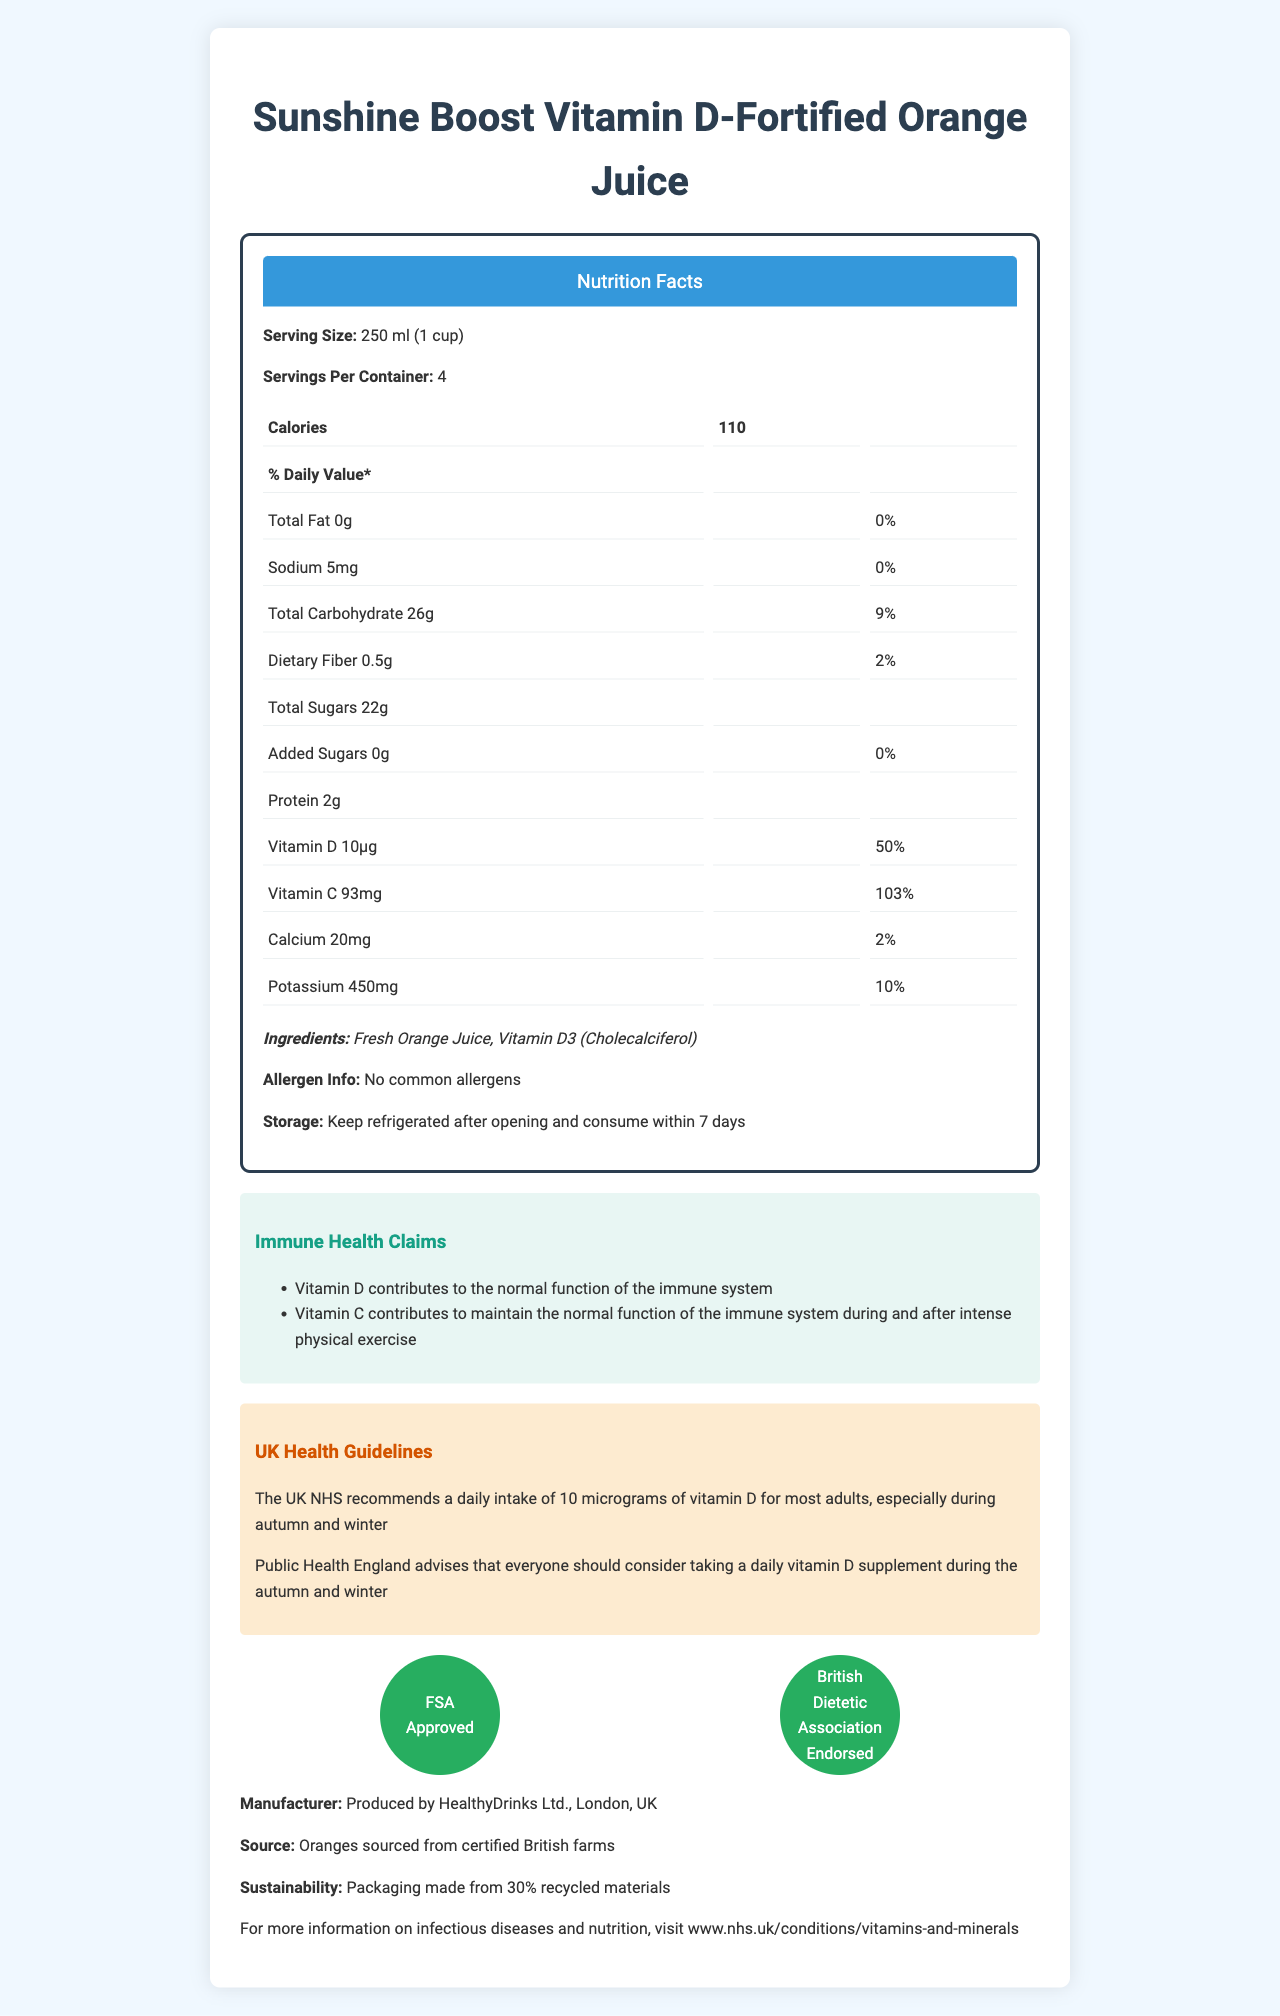How much Vitamin D does one serving of the Sunshine Boost Vitamin D-Fortified Orange Juice provide? The document lists the amount of Vitamin D per serving as 10 micrograms under the nutritional information.
Answer: 10µg What is the serving size of Sunshine Boost Vitamin D-Fortified Orange Juice? The serving size is specified as 250 ml (1 cup) in the document.
Answer: 250 ml (1 cup) How many servings are there per container? The document states that there are 4 servings per container.
Answer: 4 What are the two main ingredients in the Sunshine Boost Vitamin D-Fortified Orange Juice? The ingredients section of the document lists Fresh Orange Juice and Vitamin D3 (Cholecalciferol) as the main ingredients.
Answer: Fresh Orange Juice, Vitamin D3 (Cholecalciferol) What percentage of the daily value of Vitamin C does one serving provide? Under the nutritional information, it is stated that one serving provides 103% of the daily value of Vitamin C.
Answer: 103% What health claims are associated with Sunshine Boost Vitamin D-Fortified Orange Juice? A. Supports cardiovascular health B. Supports immune function C. Aids in digestion    D. Improves bone density The document's immune health claims section mentions that Vitamin D and Vitamin C contribute to the normal function of the immune system.
Answer: B Which certification is NOT held by Sunshine Boost Vitamin D-Fortified Orange Juice? A. FSA Approved B. British Dietetic Association Endorsed C. USDA Organic D. None of the above The document lists "FSA Approved" and "British Dietetic Association Endorsed" as certifications but does not mention "USDA Organic".
Answer: C Does the product contain any common allergens? The allergen info section of the document clearly states that there are no common allergens in the product.
Answer: No According to the document, what is the recommended daily intake of Vitamin D by the UK NHS? The UK NHS guidelines section recommends a daily intake of 10 micrograms of Vitamin D for most adults.
Answer: 10 micrograms Summarize the main idea presented in this document. This document primarily describes the nutritional benefits, particularly the immune-supporting Vitamin D and Vitamin C content, certifications, ingredient details, and sustainability efforts of the Sunshine Boost Vitamin D-Fortified Orange Juice.
Answer: The Sunshine Boost Vitamin D-Fortified Orange Juice is a nutritious beverage providing 10 micrograms of Vitamin D and 93 milligrams of Vitamin C per serving, which support immune function. It is made from fresh orange juice and contains no common allergens. The product is FSA approved and endorsed by the British Dietetic Association. Additionally, the packaging is environmentally friendly, made from 30% recycled materials. How much sugar is added to the Sunshine Boost Vitamin D-Fortified Orange Juice? The total sugars section of the document indicates that the amount of added sugars is 0g.
Answer: 0g What is the percentage of daily value for calcium provided by one serving of the juice? According to the nutritional information, one serving provides 2% of the daily value for calcium.
Answer: 2% What is the company's advice regarding the intake of Vitamin D during autumn and winter? This advice is stated clearly in the UK health guidelines section of the document.
Answer: Public Health England advises that everyone should consider taking a daily vitamin D supplement during the autumn and winter. Where are the oranges sourced from? The source info section mentions that the oranges are sourced from certified British farms.
Answer: Certified British farms What does Public Health England say about taking vitamin D supplements? This is mentioned in the UK health guidelines section of the document.
Answer: Public Health England advises that everyone should consider taking a daily vitamin D supplement during the autumn and winter. Does the product need to be refrigerated after opening? The storage instructions specify that the product should be refrigerated after opening and consumed within 7 days.
Answer: Yes What are the sustainability features of the product's packaging? This is stated in the sustainability note section of the document.
Answer: Packaging made from 30% recycled materials What is the exact sodium content in one serving of the juice? The nutritional information lists the sodium content as 5mg per serving.
Answer: 5mg How many grams of total carbohydrates are there in one serving? The nutritional information states that there are 26 grams of total carbohydrates per serving.
Answer: 26g What company manufactures the Sunshine Boost Vitamin D-Fortified Orange Juice? The manufacturer info section of the document provides this information.
Answer: HealthyDrinks Ltd., London, UK What is the recommended daily intake of Vitamin D for children under the age of one? The document only provides the general recommendation of 10 micrograms for most adults, without specific details for children.
Answer: Not enough information 